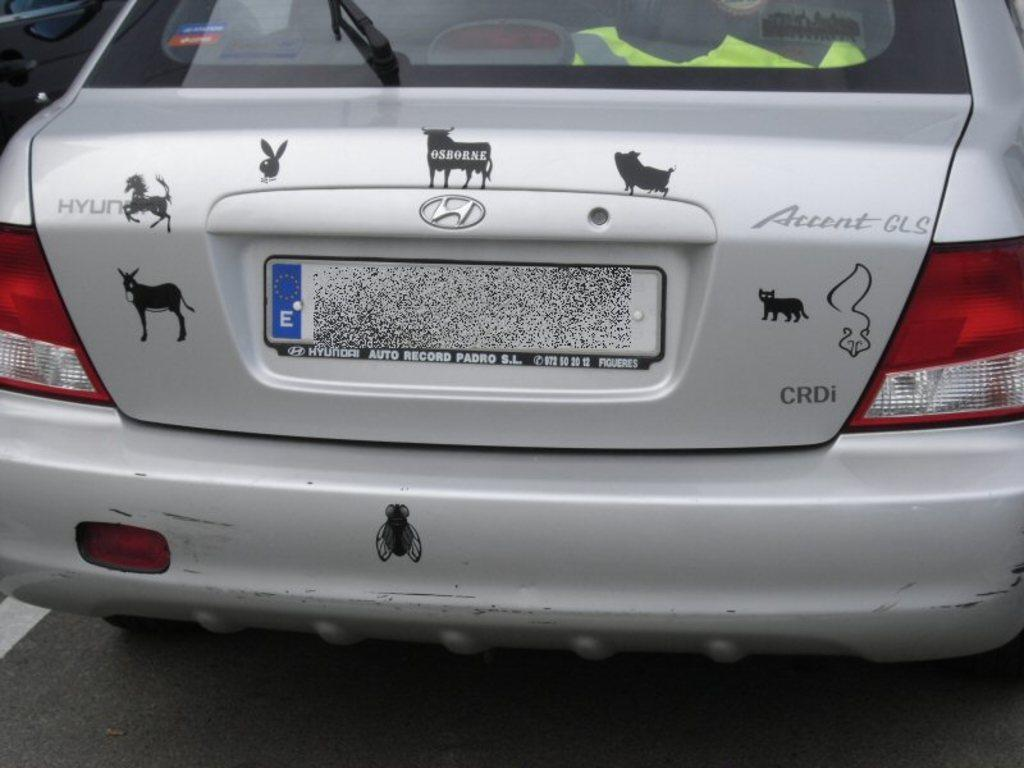What is the main subject of the image? The main subject of the image is the back side view of a car. What can be seen on the front side of the car? The car has a windshield and a wind viper. How many tail lamps are present on the car? The car has two tail lamps. Can you tell me how many quince are hanging from the car's rearview mirror in the image? There are no quince or any fruit present in the image; it features a car with specific features mentioned in the facts. 